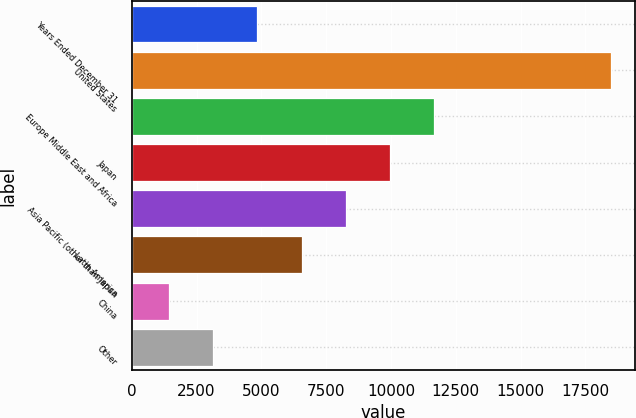Convert chart. <chart><loc_0><loc_0><loc_500><loc_500><bar_chart><fcel>Years Ended December 31<fcel>United States<fcel>Europe Middle East and Africa<fcel>Japan<fcel>Asia Pacific (other than Japan<fcel>Latin America<fcel>China<fcel>Other<nl><fcel>4843.6<fcel>18478<fcel>11660.8<fcel>9956.5<fcel>8252.2<fcel>6547.9<fcel>1435<fcel>3139.3<nl></chart> 